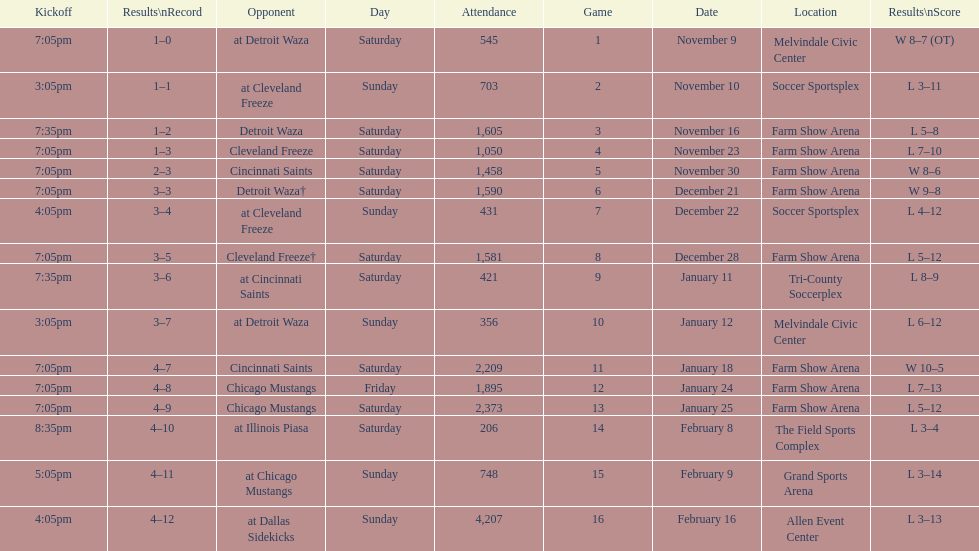How long was the teams longest losing streak? 5 games. 